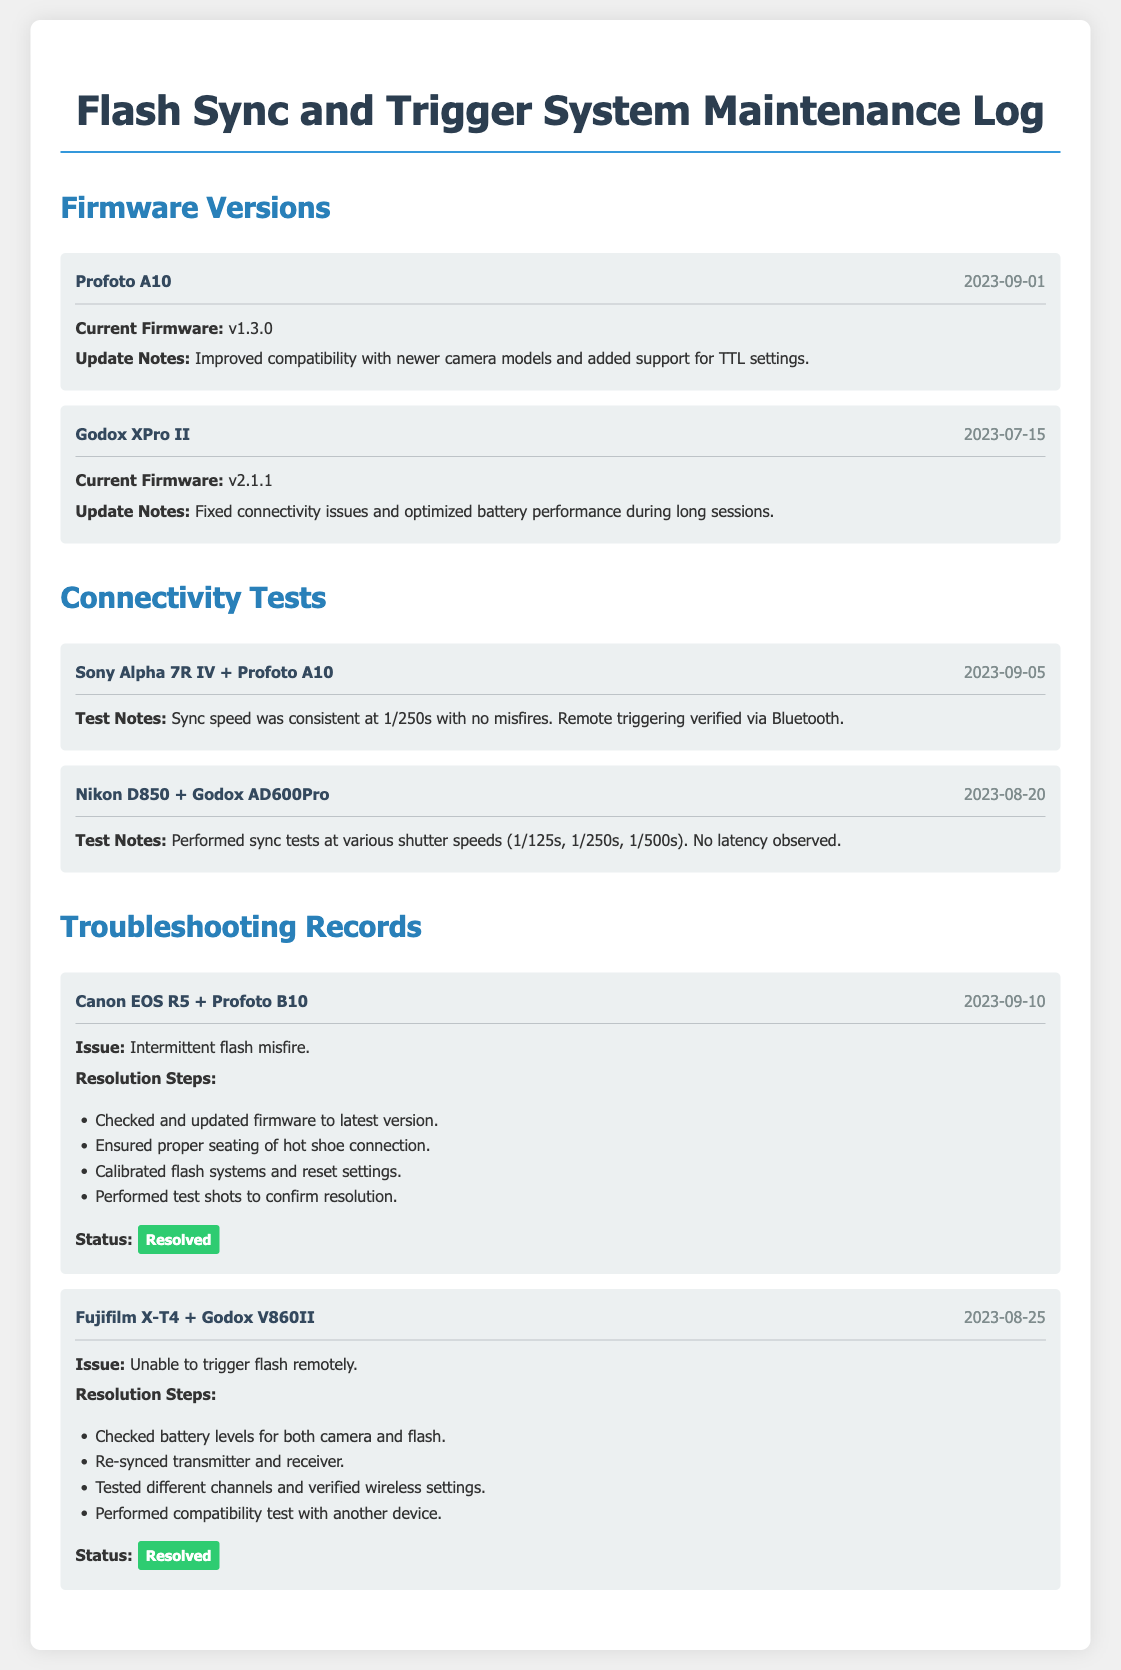What is the current firmware version for Profoto A10? The current firmware version for Profoto A10 is noted as v1.3.0 in the document.
Answer: v1.3.0 When was the last firmware update for Godox XPro II? The last firmware update for Godox XPro II was on 2023-07-15 according to the document.
Answer: 2023-07-15 What is the sync speed observed with Sony Alpha 7R IV and Profoto A10? The sync speed observed with Sony Alpha 7R IV and Profoto A10 was consistent at 1/250s, as shown in the connectivity tests section.
Answer: 1/250s What issue occurred with Canon EOS R5 and Profoto B10? The issue recorded with Canon EOS R5 and Profoto B10 was intermittent flash misfire.
Answer: intermittent flash misfire How many steps were involved to resolve the issue with Fujifilm X-T4 and Godox V860II? The resolution steps for the Fujifilm X-T4 and Godox V860II issue included four specific actions, as listed in the document.
Answer: four What was one of the update notes for Profoto A10 firmware? One of the update notes for the Profoto A10 firmware mentioned improved compatibility with newer camera models.
Answer: improved compatibility with newer camera models Which camera model was tested with Godox AD600Pro on 2023-08-20? The camera model tested with Godox AD600Pro on 2023-08-20 was Nikon D850.
Answer: Nikon D850 What was the status of the intermittent flash misfire issue after troubleshooting? The status of the intermittent flash misfire issue after troubleshooting was resolved, as indicated in the document.
Answer: Resolved 